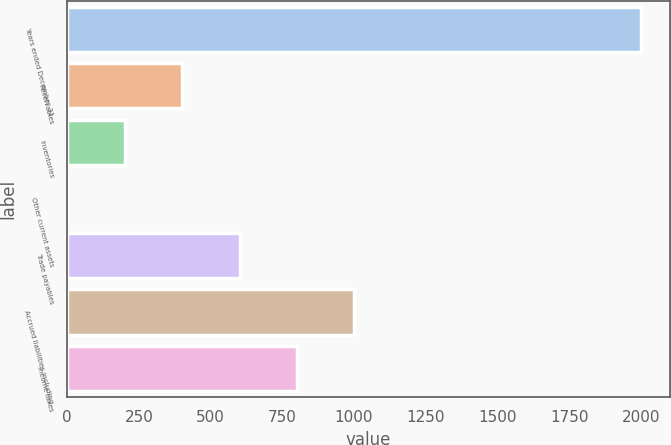Convert chart. <chart><loc_0><loc_0><loc_500><loc_500><bar_chart><fcel>Years ended December 31<fcel>Receivables<fcel>Inventories<fcel>Other current assets<fcel>Trade payables<fcel>Accrued liabilities including<fcel>Income taxes<nl><fcel>2002<fcel>400.64<fcel>200.47<fcel>0.3<fcel>600.81<fcel>1001.15<fcel>800.98<nl></chart> 